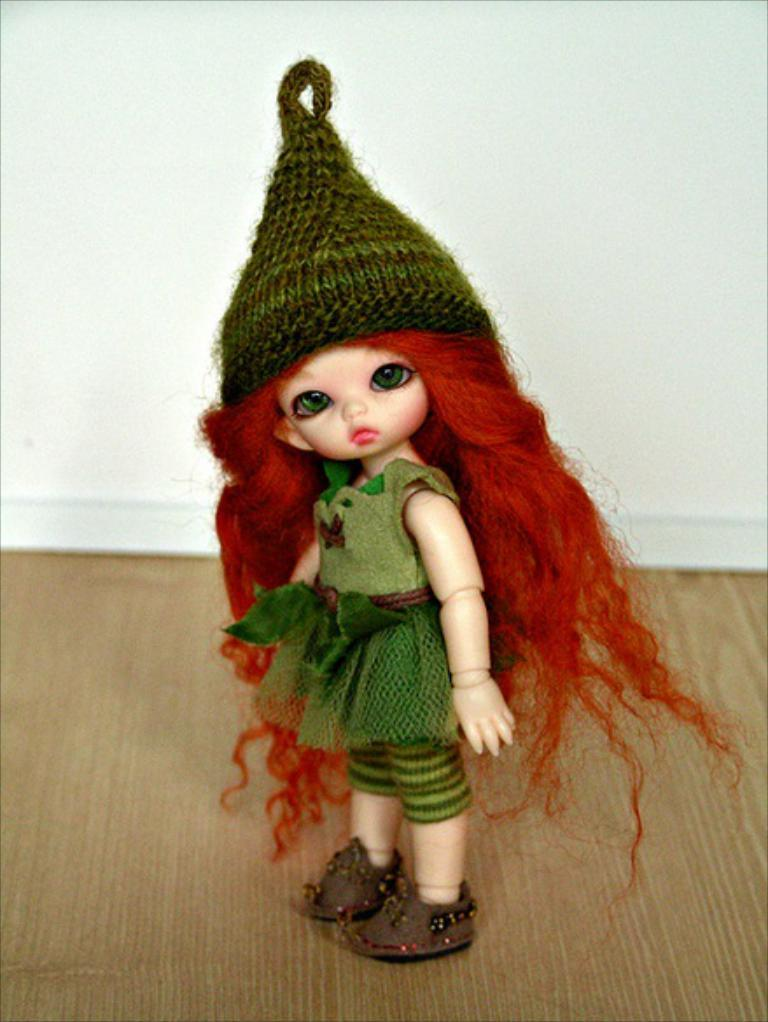What type of toy is present in the image? There is a Barbie toy in the image. What color is the dress that the Barbie toy is wearing? The Barbie toy is associated with a green color dress. What can be seen in the background of the image? There is a white color wall in the background of the image. How does the Barbie toy burst into the air in the image? The Barbie toy does not burst into the air in the image; it is a stationary toy on a surface. 